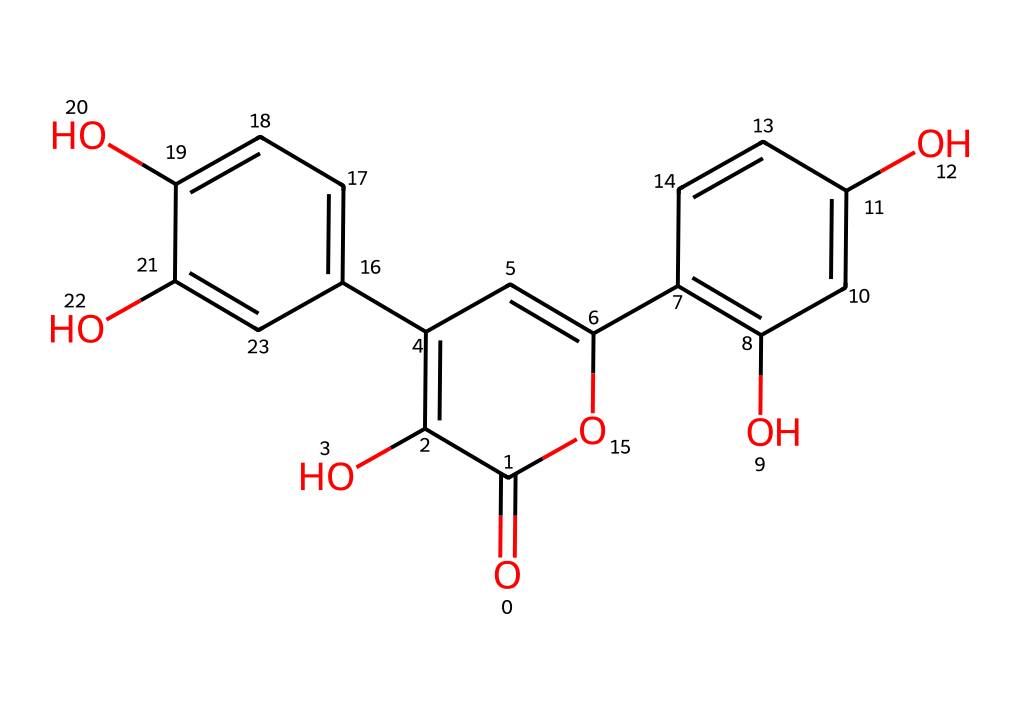what is the molecular formula for quercetin? The molecular formula can be derived from the count of carbon (C), hydrogen (H), and oxygen (O) atoms present in the structure. By analyzing the structure, you can see there are 15 carbon atoms, 10 hydrogen atoms, and 7 oxygen atoms. Therefore, the molecular formula is C15H10O7.
Answer: C15H10O7 how many hydroxyl (–OH) groups are present in quercetin? Inspecting the chemical structure, each hydroxyl group is typically represented by an -OH, which can be located on certain carbon atoms. In quercetin's structure, there are 5 hydroxyl groups identified.
Answer: 5 which type of antioxidant is quercetin categorized as? Quercetin is primarily known as a flavonoid, which is a specific type of antioxidant present in various plants and foods. This classification is based on its chemical structure, which has a flavone backbone.
Answer: flavonoid how many rings are present in the quercetin structure? A careful examination of the structure shows that there are 3 interconnected rings: two benzene rings and one heterocyclic structure in the middle. Therefore, the total number of rings is 3.
Answer: 3 what is the significance of the hydroxyl groups in quercetin? The hydroxyl groups present in quercetin act as active sites for hydrogen donation in redox reactions, which is fundamental to its antioxidant activity. Their presence contributes to the ability of quercetin to neutralize harmful free radicals.
Answer: antioxidant activity which aromatic system is present in the quercetin molecule? The quercetin molecule contains a flavone aromatic system, which consists of 3 interconnected rings, including conjugated double bonds that contribute to its aromatic characteristics. This enables its effective interaction with free radicals.
Answer: flavone how does the structure of quercetin contribute to its solubility? The presence of multiple hydroxyl groups in the quercetin structure increases its polarity, enhancing its solubility in polar solvents such as water. This is because hydroxyl groups can form hydrogen bonds with water molecules, thus facilitating solubility.
Answer: increased solubility 